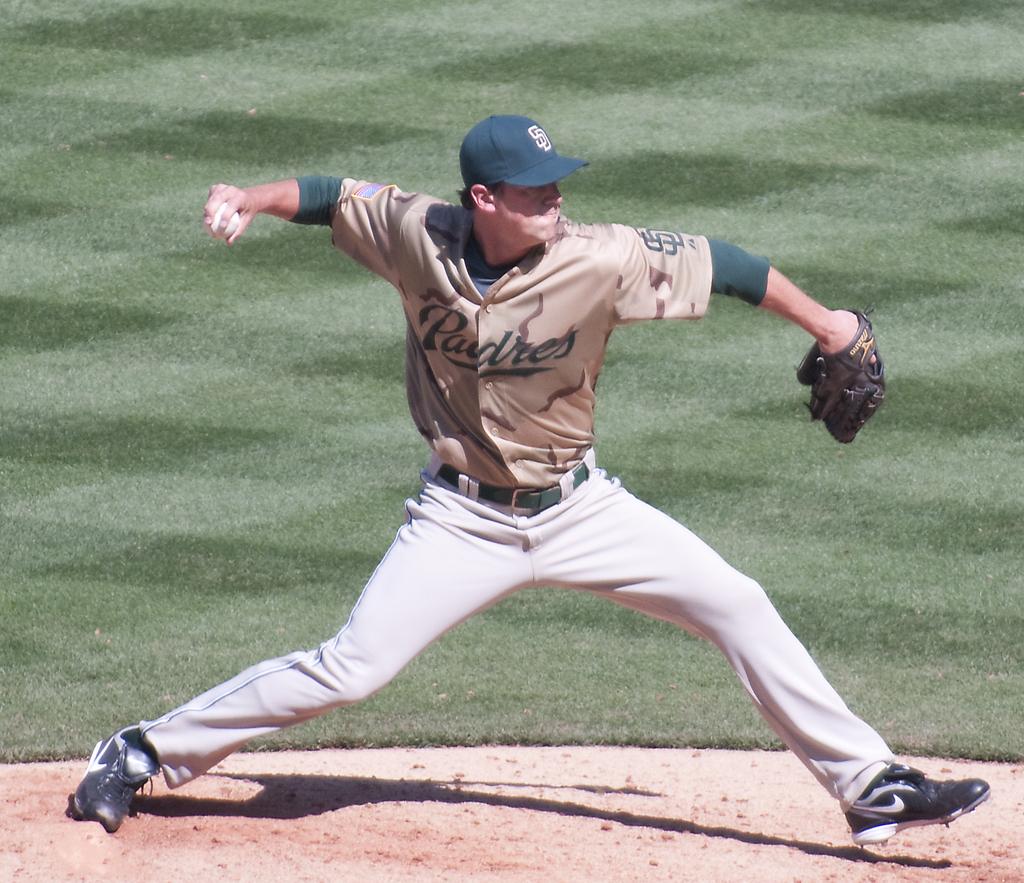What team uniform is the player wearing?
Provide a short and direct response. Padres. 